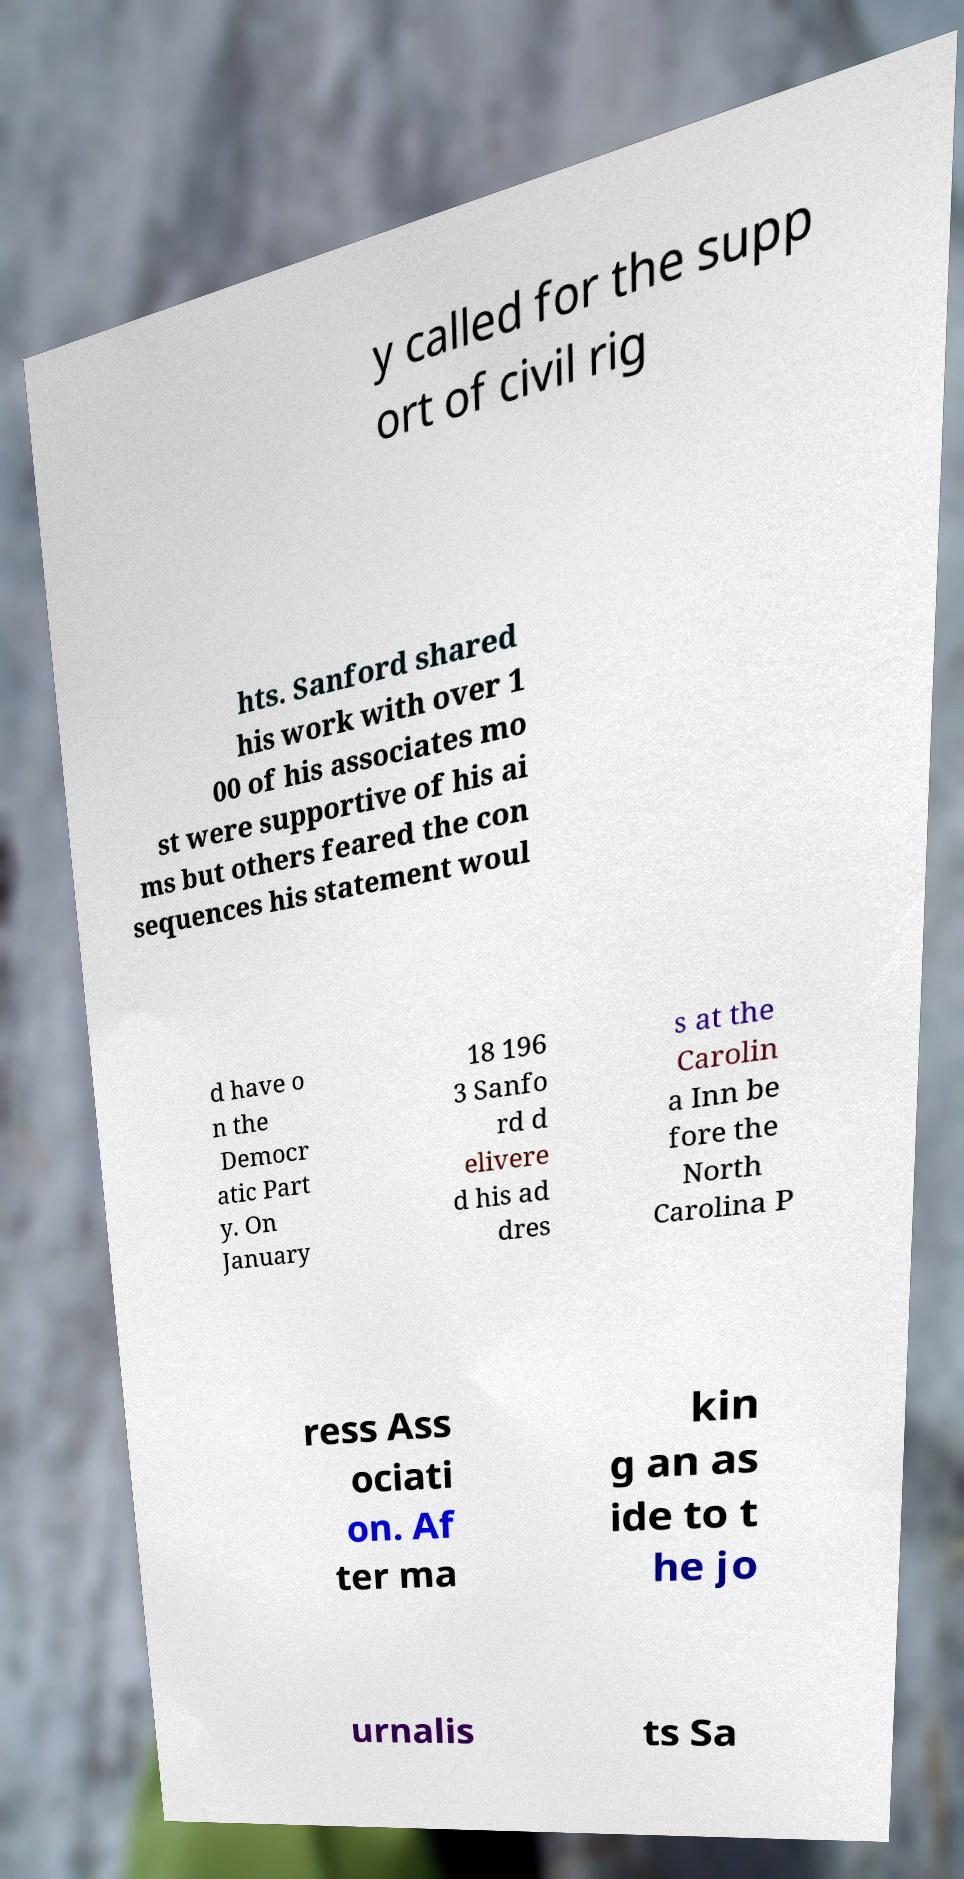I need the written content from this picture converted into text. Can you do that? y called for the supp ort of civil rig hts. Sanford shared his work with over 1 00 of his associates mo st were supportive of his ai ms but others feared the con sequences his statement woul d have o n the Democr atic Part y. On January 18 196 3 Sanfo rd d elivere d his ad dres s at the Carolin a Inn be fore the North Carolina P ress Ass ociati on. Af ter ma kin g an as ide to t he jo urnalis ts Sa 